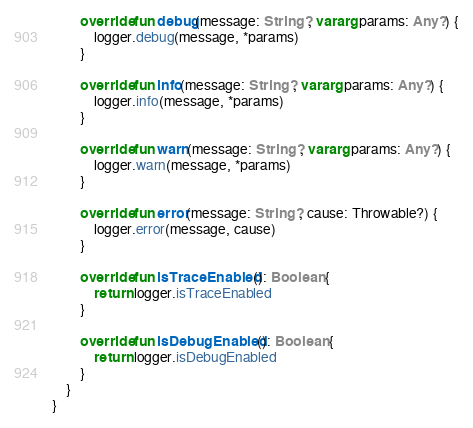<code> <loc_0><loc_0><loc_500><loc_500><_Kotlin_>        override fun debug(message: String?, vararg params: Any?) {
            logger.debug(message, *params)
        }

        override fun info(message: String?, vararg params: Any?) {
            logger.info(message, *params)
        }

        override fun warn(message: String?, vararg params: Any?) {
            logger.warn(message, *params)
        }

        override fun error(message: String?, cause: Throwable?) {
            logger.error(message, cause)
        }

        override fun isTraceEnabled(): Boolean {
            return logger.isTraceEnabled
        }

        override fun isDebugEnabled(): Boolean {
            return logger.isDebugEnabled
        }
    }
}</code> 